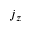Convert formula to latex. <formula><loc_0><loc_0><loc_500><loc_500>j _ { z }</formula> 